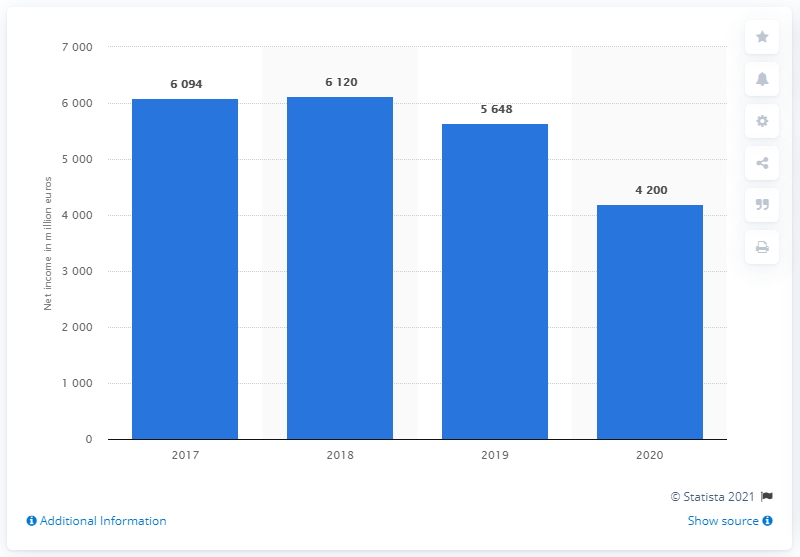Indicate a few pertinent items in this graphic. Siemens AG's net income in the 2020 financial year was 4,200. In 2019, the net income of Siemens AG was 4,200. 